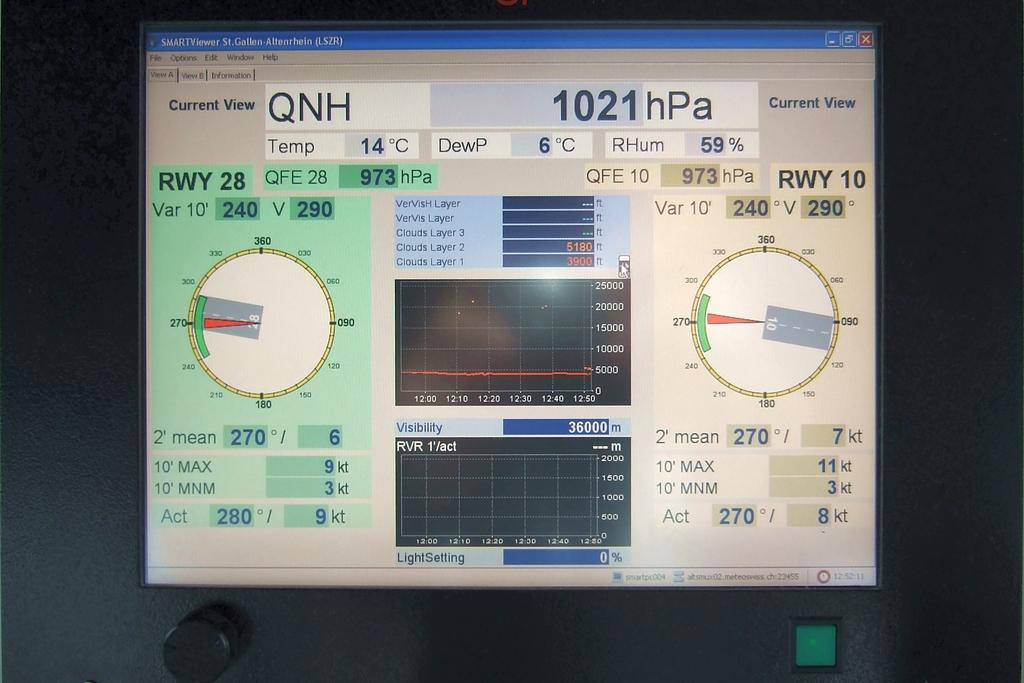Provide a one-sentence caption for the provided image. a monitor with a 1021 hPa message on it. 